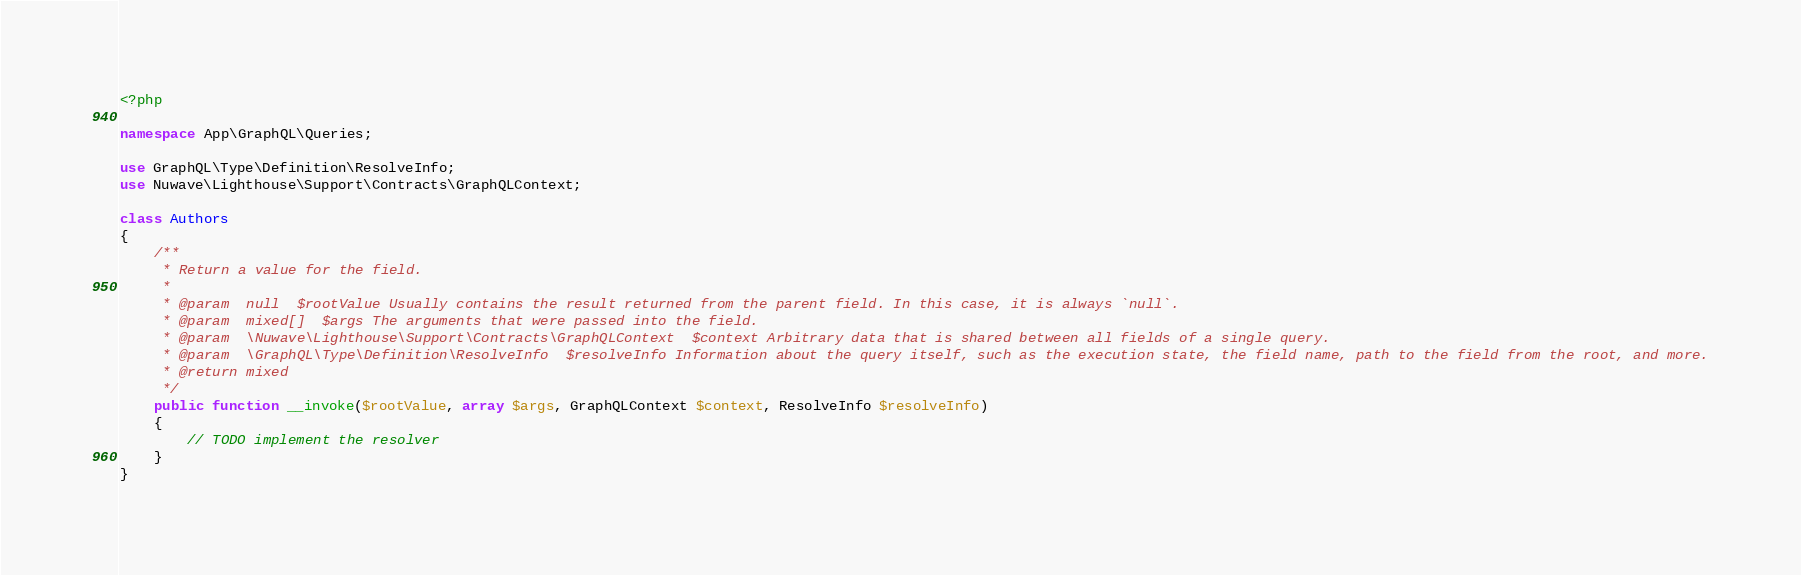<code> <loc_0><loc_0><loc_500><loc_500><_PHP_><?php

namespace App\GraphQL\Queries;

use GraphQL\Type\Definition\ResolveInfo;
use Nuwave\Lighthouse\Support\Contracts\GraphQLContext;

class Authors
{
	/**
	 * Return a value for the field.
	 *
	 * @param  null  $rootValue Usually contains the result returned from the parent field. In this case, it is always `null`.
	 * @param  mixed[]  $args The arguments that were passed into the field.
	 * @param  \Nuwave\Lighthouse\Support\Contracts\GraphQLContext  $context Arbitrary data that is shared between all fields of a single query.
	 * @param  \GraphQL\Type\Definition\ResolveInfo  $resolveInfo Information about the query itself, such as the execution state, the field name, path to the field from the root, and more.
	 * @return mixed
	 */
	public function __invoke($rootValue, array $args, GraphQLContext $context, ResolveInfo $resolveInfo)
	{
		// TODO implement the resolver
	}
}
</code> 